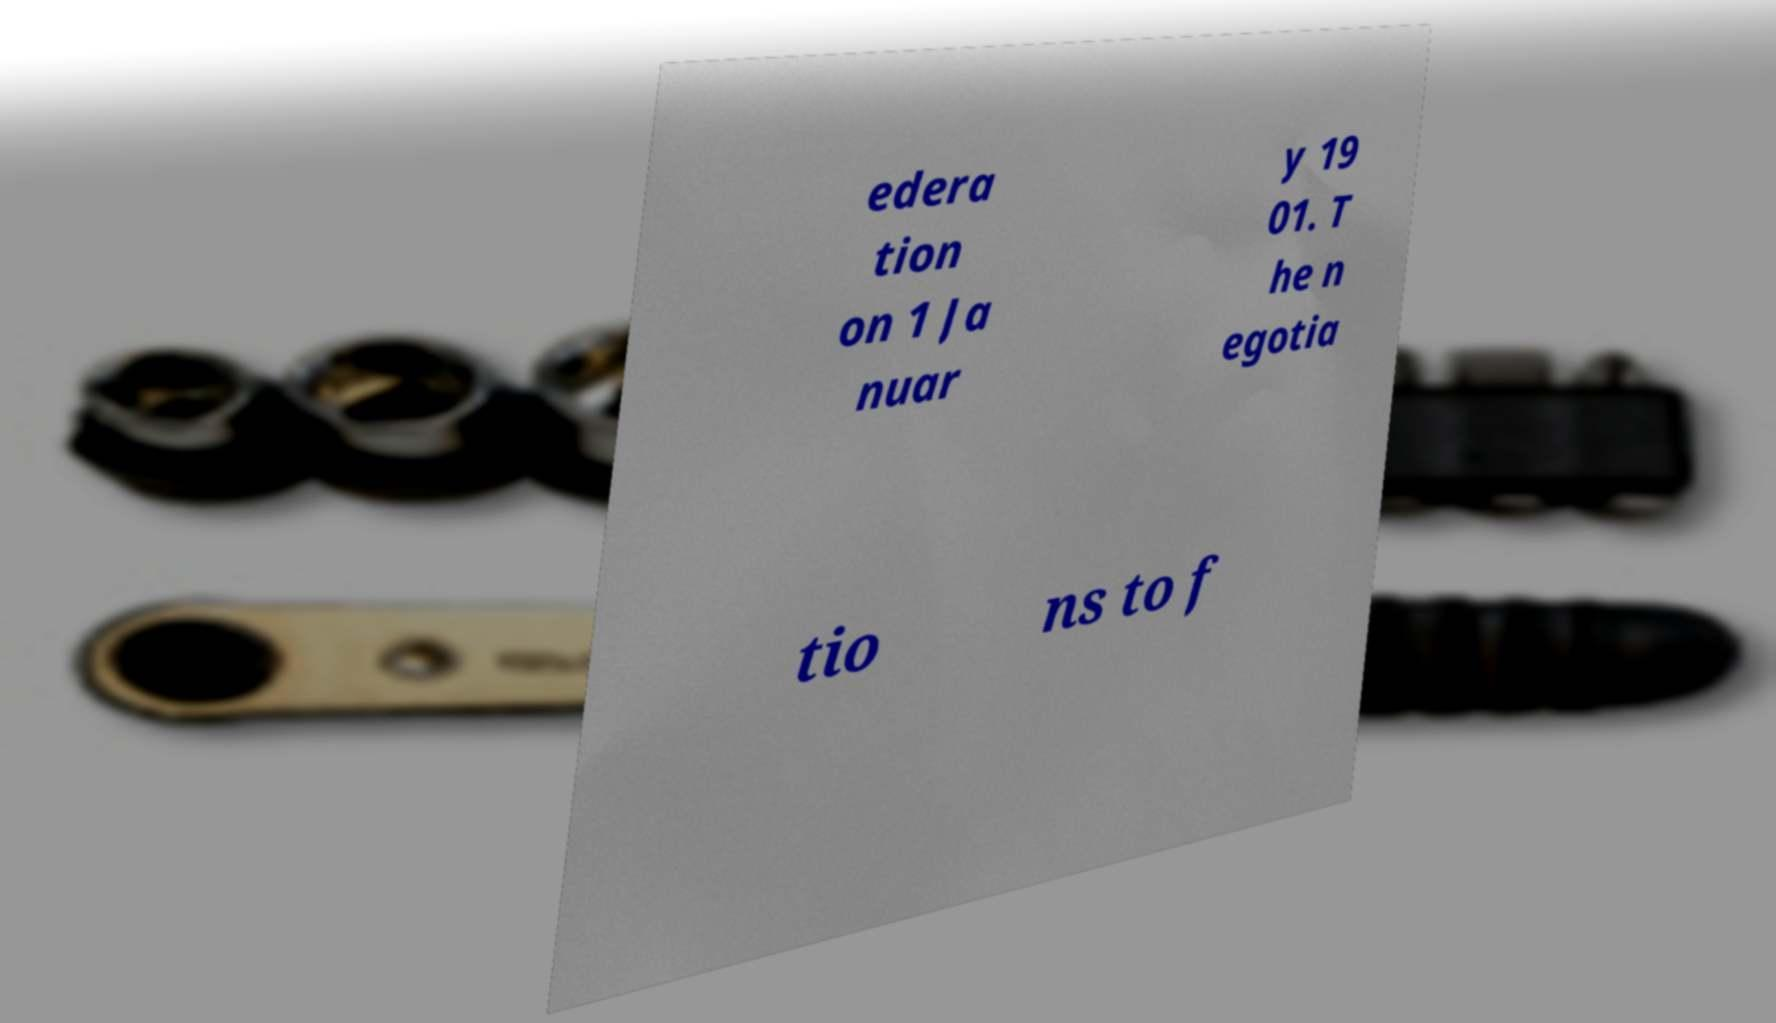Could you extract and type out the text from this image? edera tion on 1 Ja nuar y 19 01. T he n egotia tio ns to f 